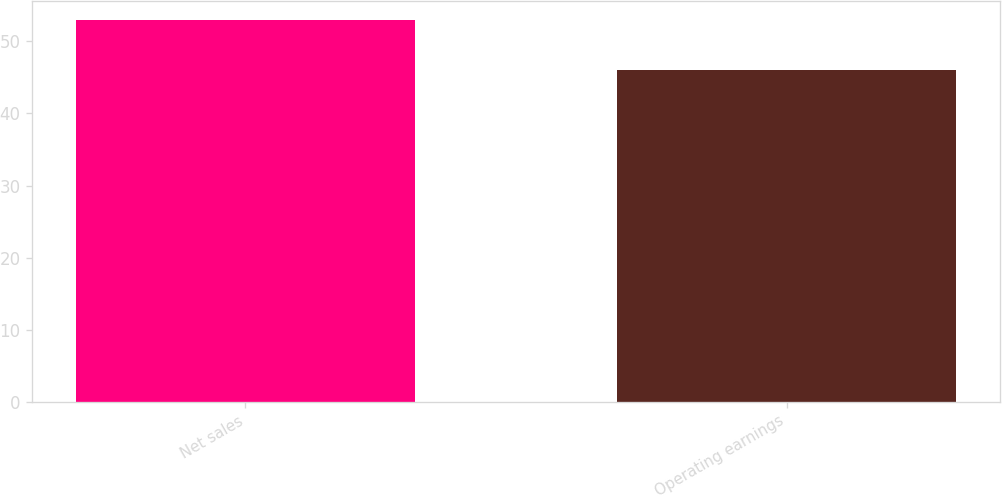<chart> <loc_0><loc_0><loc_500><loc_500><bar_chart><fcel>Net sales<fcel>Operating earnings<nl><fcel>53<fcel>46<nl></chart> 